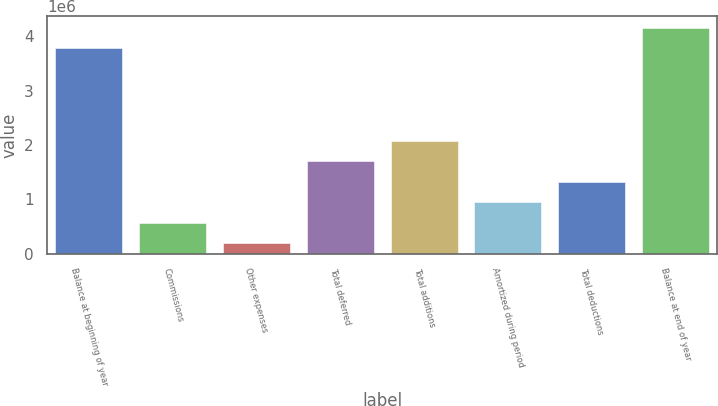Convert chart. <chart><loc_0><loc_0><loc_500><loc_500><bar_chart><fcel>Balance at beginning of year<fcel>Commissions<fcel>Other expenses<fcel>Total deferred<fcel>Total additions<fcel>Amortized during period<fcel>Total deductions<fcel>Balance at end of year<nl><fcel>3.78316e+06<fcel>570599<fcel>194214<fcel>1.69975e+06<fcel>2.07614e+06<fcel>946984<fcel>1.32337e+06<fcel>4.15954e+06<nl></chart> 